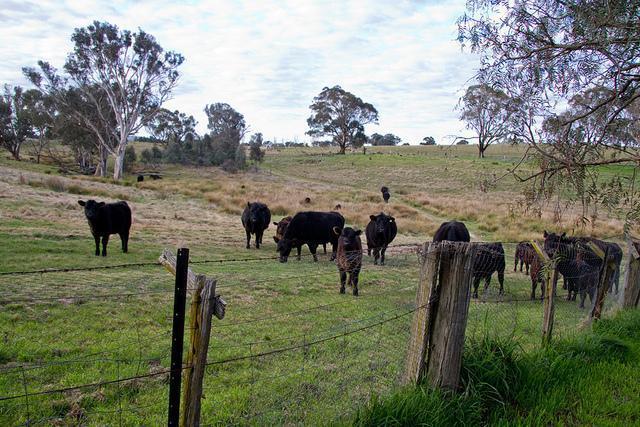How many goats are in the photo?
Give a very brief answer. 0. How many cows are in the photo?
Give a very brief answer. 3. 